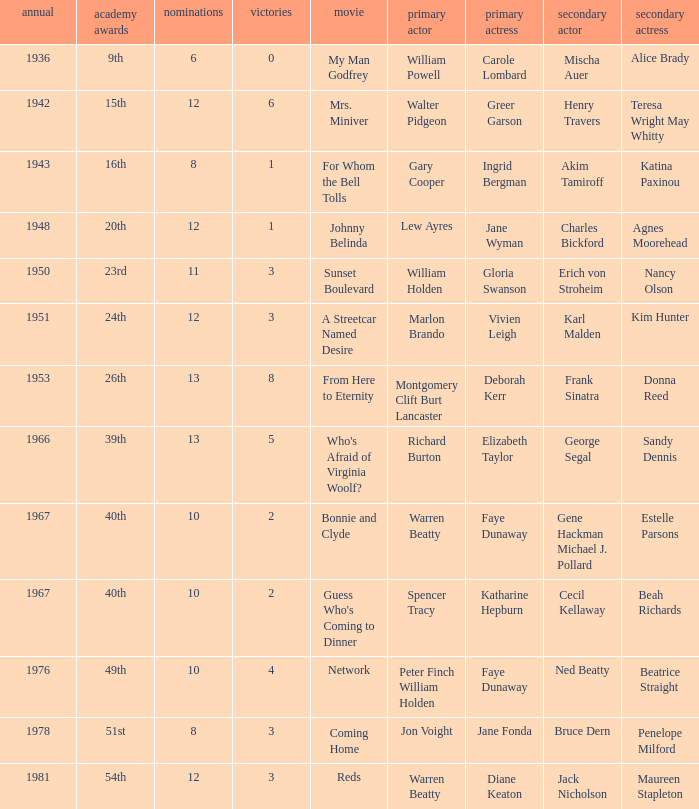Who was the supporting actress in a film with Diane Keaton as the leading actress? Maureen Stapleton. 